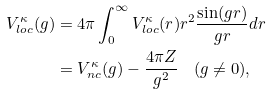Convert formula to latex. <formula><loc_0><loc_0><loc_500><loc_500>V _ { l o c } ^ { \kappa } ( g ) & = 4 \pi \int _ { 0 } ^ { \infty } V _ { l o c } ^ { \kappa } ( r ) r ^ { 2 } \frac { \sin ( g r ) } { g r } d r \\ & = V _ { n c } ^ { \kappa } ( g ) - \frac { 4 \pi Z } { g ^ { 2 } } \quad ( g \ne 0 ) ,</formula> 